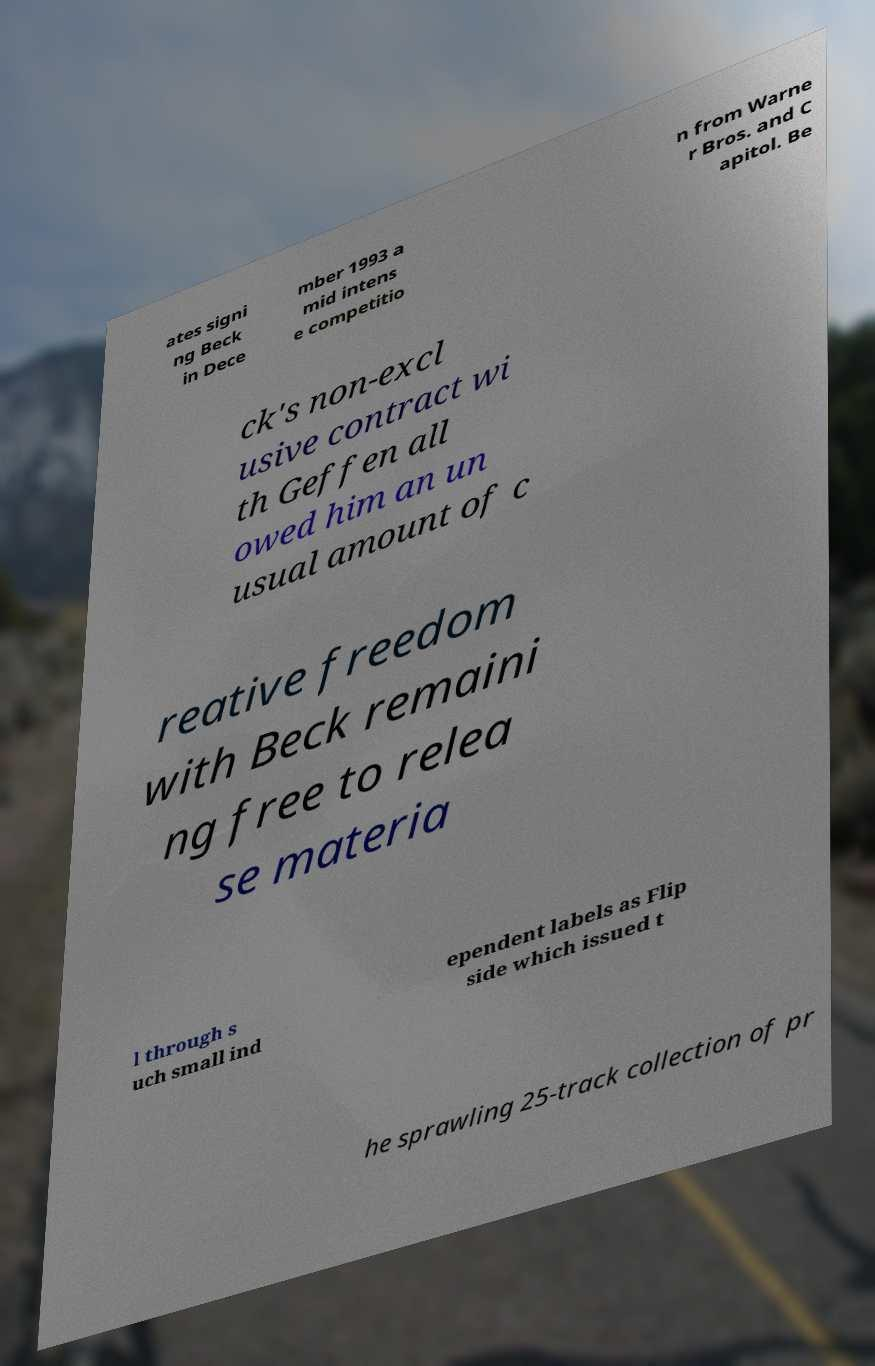Can you read and provide the text displayed in the image?This photo seems to have some interesting text. Can you extract and type it out for me? ates signi ng Beck in Dece mber 1993 a mid intens e competitio n from Warne r Bros. and C apitol. Be ck's non-excl usive contract wi th Geffen all owed him an un usual amount of c reative freedom with Beck remaini ng free to relea se materia l through s uch small ind ependent labels as Flip side which issued t he sprawling 25-track collection of pr 